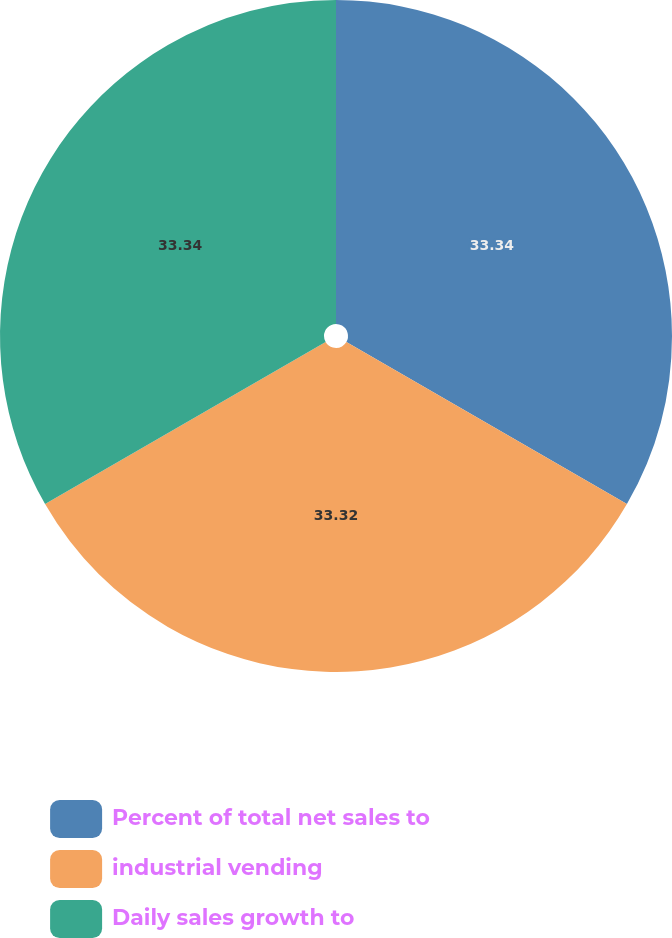Convert chart to OTSL. <chart><loc_0><loc_0><loc_500><loc_500><pie_chart><fcel>Percent of total net sales to<fcel>industrial vending<fcel>Daily sales growth to<nl><fcel>33.34%<fcel>33.32%<fcel>33.34%<nl></chart> 